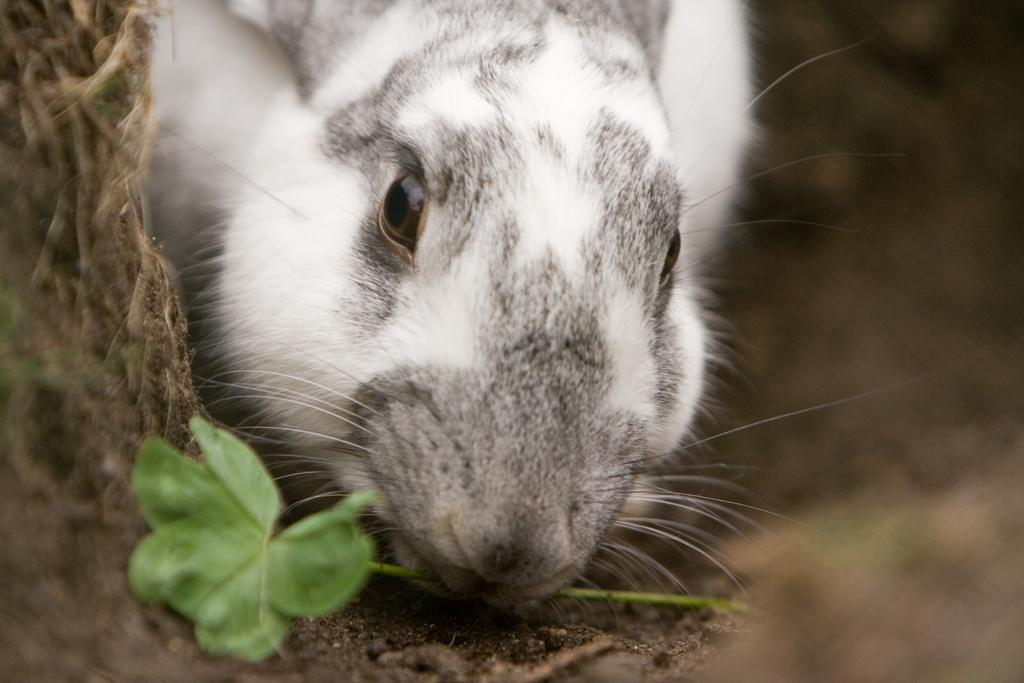What type of animal is present in the image? There is an animal in the image. What is the animal doing in the image? The animal has a leaf in its mouth. What can be seen beneath the animal in the image? The ground is visible in the image. What type of group is the animal a part of in the image? There is no indication in the image that the animal is a part of any group. What type of weather condition is present in the image? The provided facts do not mention any specific weather condition, such as sleet. 